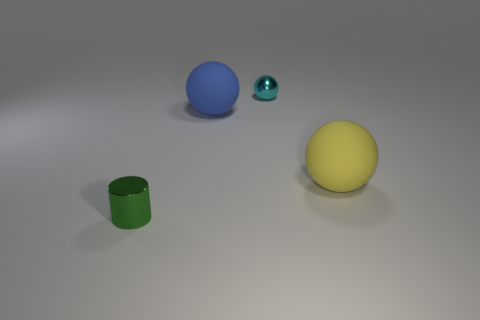Add 2 large cyan objects. How many objects exist? 6 Subtract all spheres. How many objects are left? 1 Subtract all yellow objects. Subtract all brown metallic balls. How many objects are left? 3 Add 3 big yellow spheres. How many big yellow spheres are left? 4 Add 4 purple shiny cubes. How many purple shiny cubes exist? 4 Subtract 0 red cubes. How many objects are left? 4 